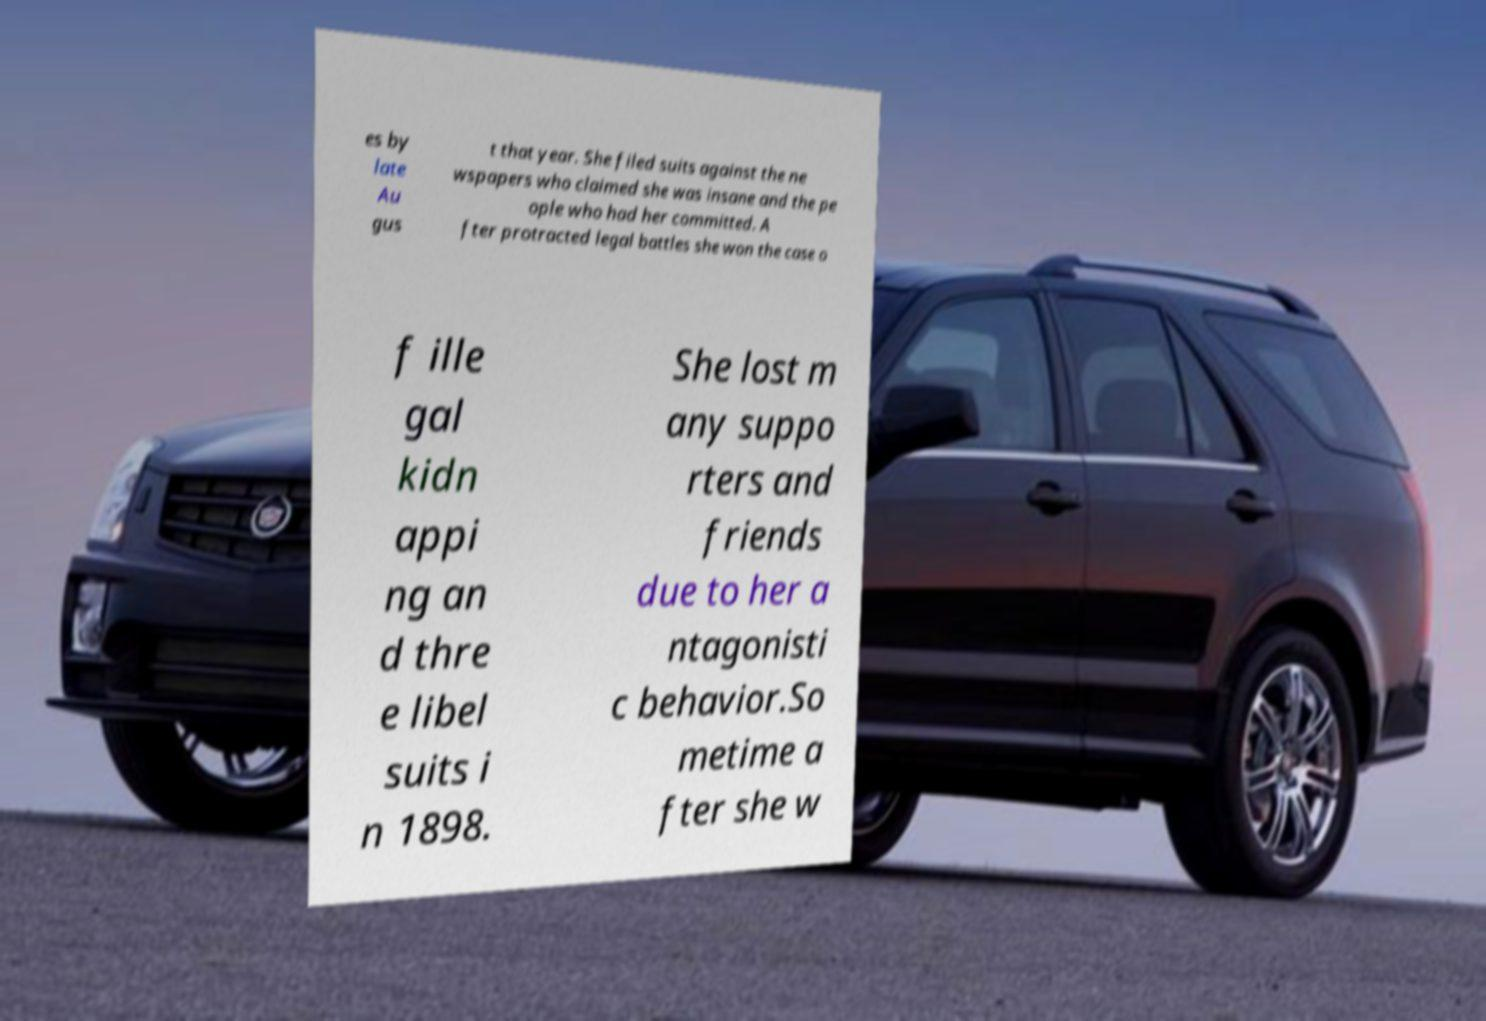Could you assist in decoding the text presented in this image and type it out clearly? es by late Au gus t that year. She filed suits against the ne wspapers who claimed she was insane and the pe ople who had her committed. A fter protracted legal battles she won the case o f ille gal kidn appi ng an d thre e libel suits i n 1898. She lost m any suppo rters and friends due to her a ntagonisti c behavior.So metime a fter she w 